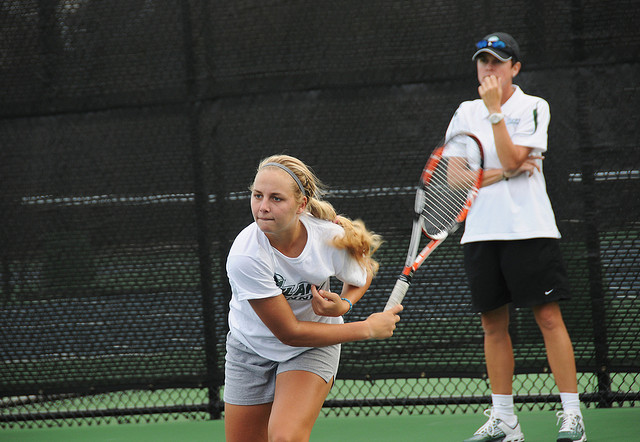<image>What does her shirt tell you you've met? The shirt does not clearly indicate who you've met. It could possibly suggest a tennis player or a champ, but it's ambiguous. What does her shirt tell you you've met? I don't know what her shirt tells you you've met. It can be 'match', 'tennis player', 'champ', 'fate' or 'beast'. 